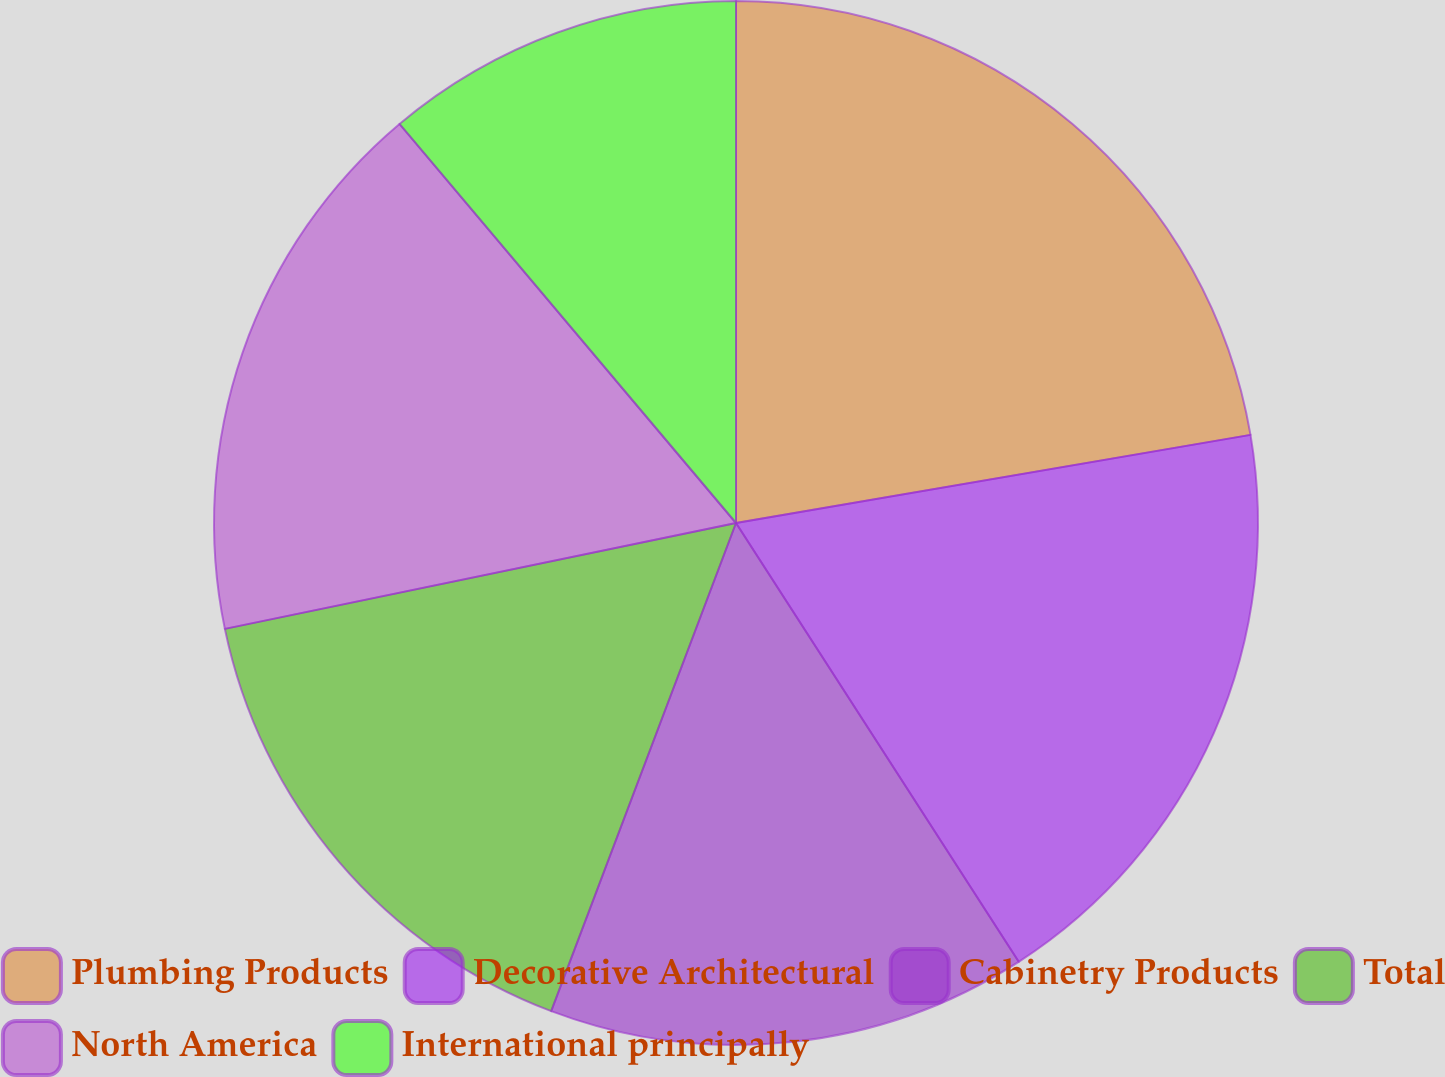<chart> <loc_0><loc_0><loc_500><loc_500><pie_chart><fcel>Plumbing Products<fcel>Decorative Architectural<fcel>Cabinetry Products<fcel>Total<fcel>North America<fcel>International principally<nl><fcel>22.3%<fcel>18.59%<fcel>14.87%<fcel>15.99%<fcel>17.1%<fcel>11.15%<nl></chart> 